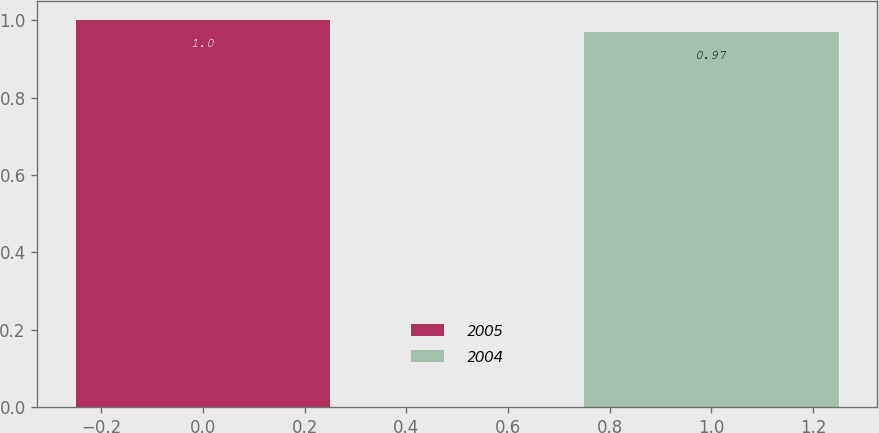Convert chart. <chart><loc_0><loc_0><loc_500><loc_500><bar_chart><fcel>2005<fcel>2004<nl><fcel>1<fcel>0.97<nl></chart> 